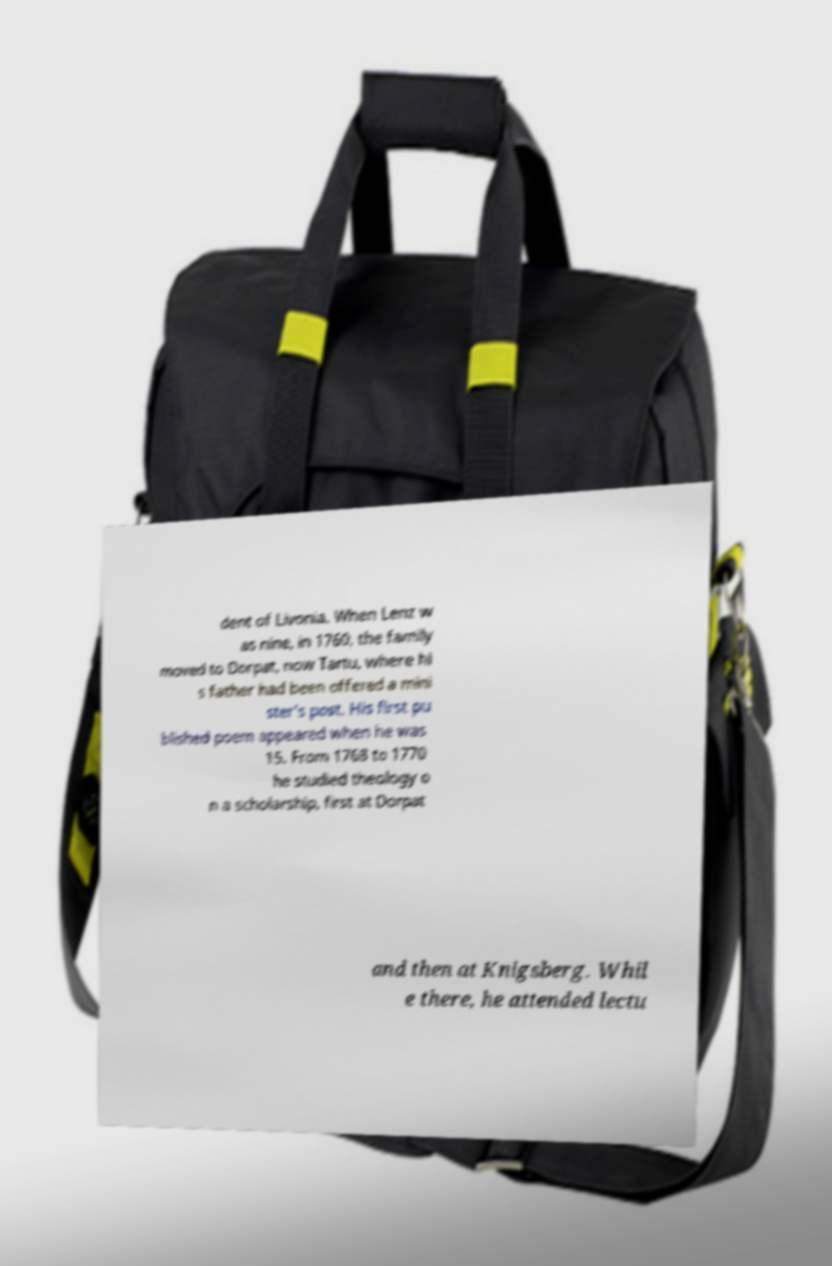What messages or text are displayed in this image? I need them in a readable, typed format. dent of Livonia. When Lenz w as nine, in 1760, the family moved to Dorpat, now Tartu, where hi s father had been offered a mini ster's post. His first pu blished poem appeared when he was 15. From 1768 to 1770 he studied theology o n a scholarship, first at Dorpat and then at Knigsberg. Whil e there, he attended lectu 